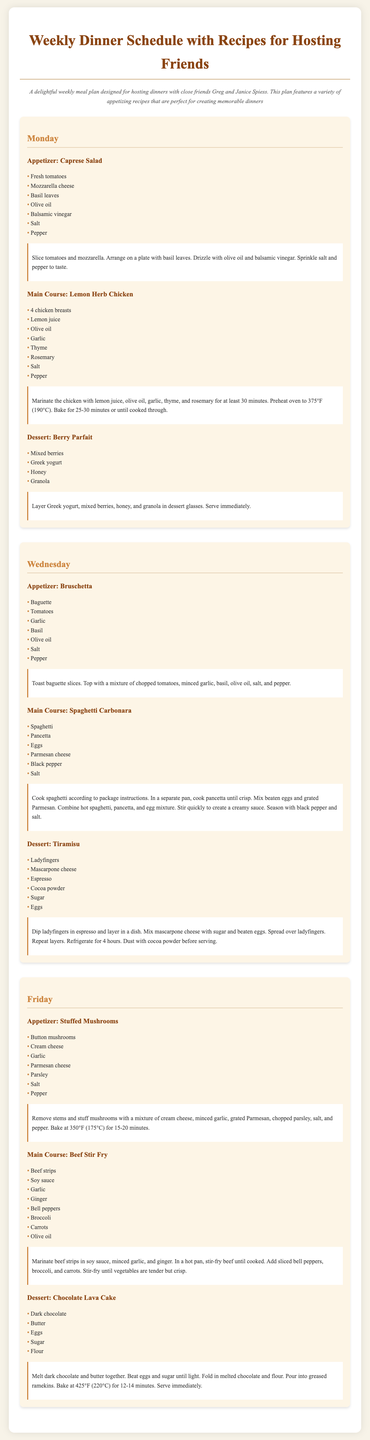what is the title of the document? The title of the document is prominently displayed in the header section, indicating the contents related to meal planning for hosting friends.
Answer: Weekly Dinner Schedule with Recipes for Hosting Friends how many days are covered in the meal plan? The meal plan specifically outlines the dinner schedule for three days of the week.
Answer: 3 what dessert is served on Monday? The dessert mentioned under Monday in the meal plan provides a sweet treat following the main course.
Answer: Berry Parfait what is the main course for Wednesday? The main course outlined for Wednesday depicts a classic Italian dish suitable for hosting guests.
Answer: Spaghetti Carbonara how long should Tiramisu be refrigerated? The refrigeration time for Tiramisu ensures proper setting and enhances flavor, as stated in the recipe instructions.
Answer: 4 hours which dish includes mushrooms as an ingredient? The dish that features mushrooms is specifically noted as a stuffed variant in the appetizers section.
Answer: Stuffed Mushrooms what is the cooking temperature for baking the Lemon Herb Chicken? The baking temperature for this chicken dish is clearly specified to ensure proper cooking.
Answer: 375°F what are the main ingredients of the Beef Stir Fry? The recipe lists various ingredients for this stir-fry, focusing on protein and vegetables that make the dish flavorful.
Answer: Beef strips, Soy sauce, Garlic, Ginger, Bell peppers, Broccoli, Carrots, Olive oil 